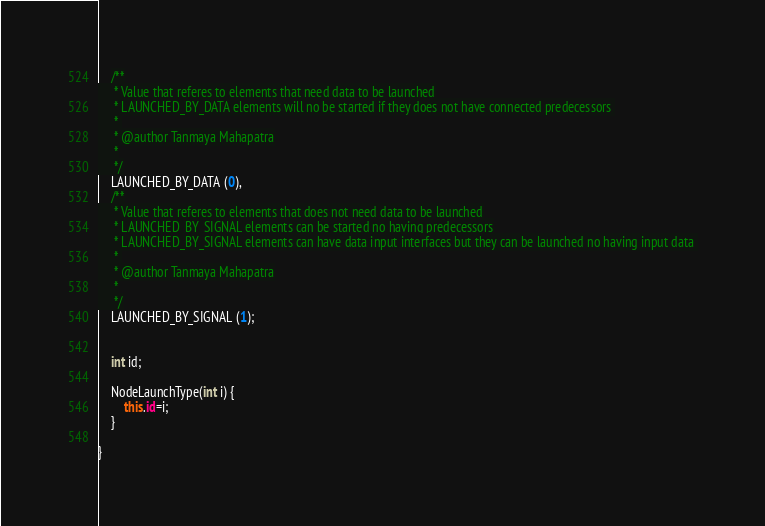Convert code to text. <code><loc_0><loc_0><loc_500><loc_500><_Java_>	/**
	 * Value that referes to elements that need data to be launched
	 * LAUNCHED_BY_DATA elements will no be started if they does not have connected predecessors 
	 * 
	 * @author Tanmaya Mahapatra
	 *
	 */
	LAUNCHED_BY_DATA (0),
	/**
	 * Value that referes to elements that does not need data to be launched
	 * LAUNCHED_BY_SIGNAL elements can be started no having predecessors
	 * LAUNCHED_BY_SIGNAL elements can have data input interfaces but they can be launched no having input data 
	 * 
	 * @author Tanmaya Mahapatra
	 *
	 */
	LAUNCHED_BY_SIGNAL (1);
	
	
	int id;
	
	NodeLaunchType(int i) {
		this.id=i;
	}
	
}
</code> 